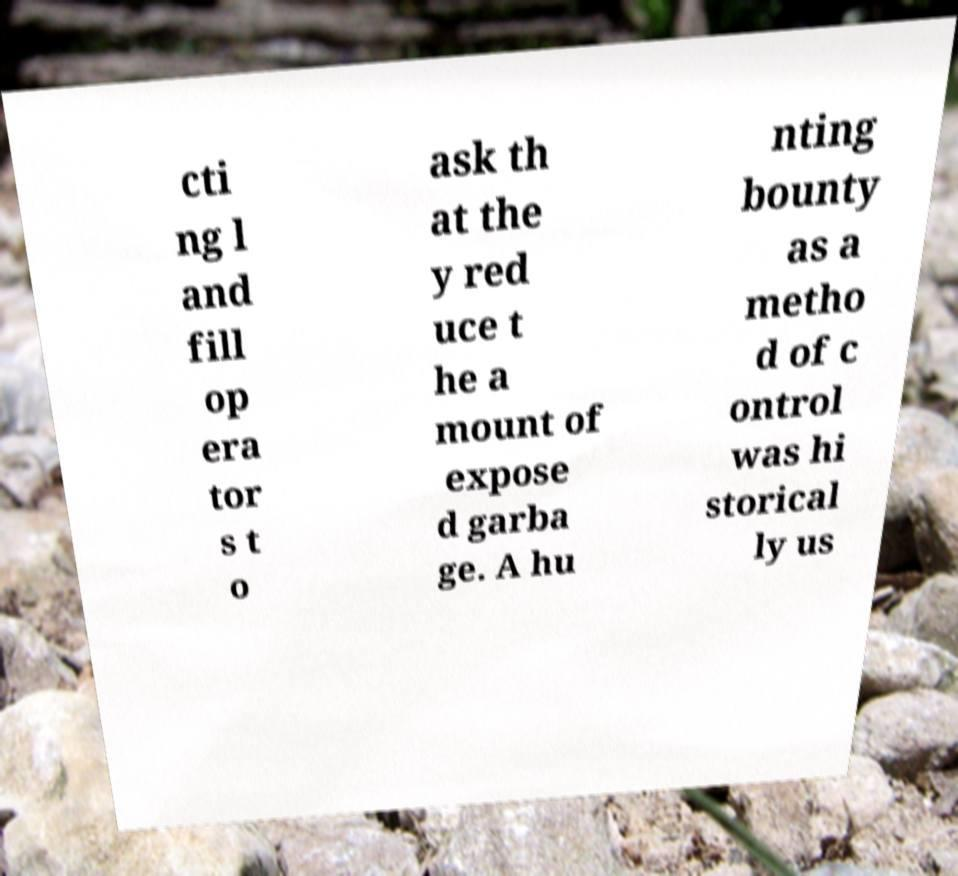Could you extract and type out the text from this image? cti ng l and fill op era tor s t o ask th at the y red uce t he a mount of expose d garba ge. A hu nting bounty as a metho d of c ontrol was hi storical ly us 